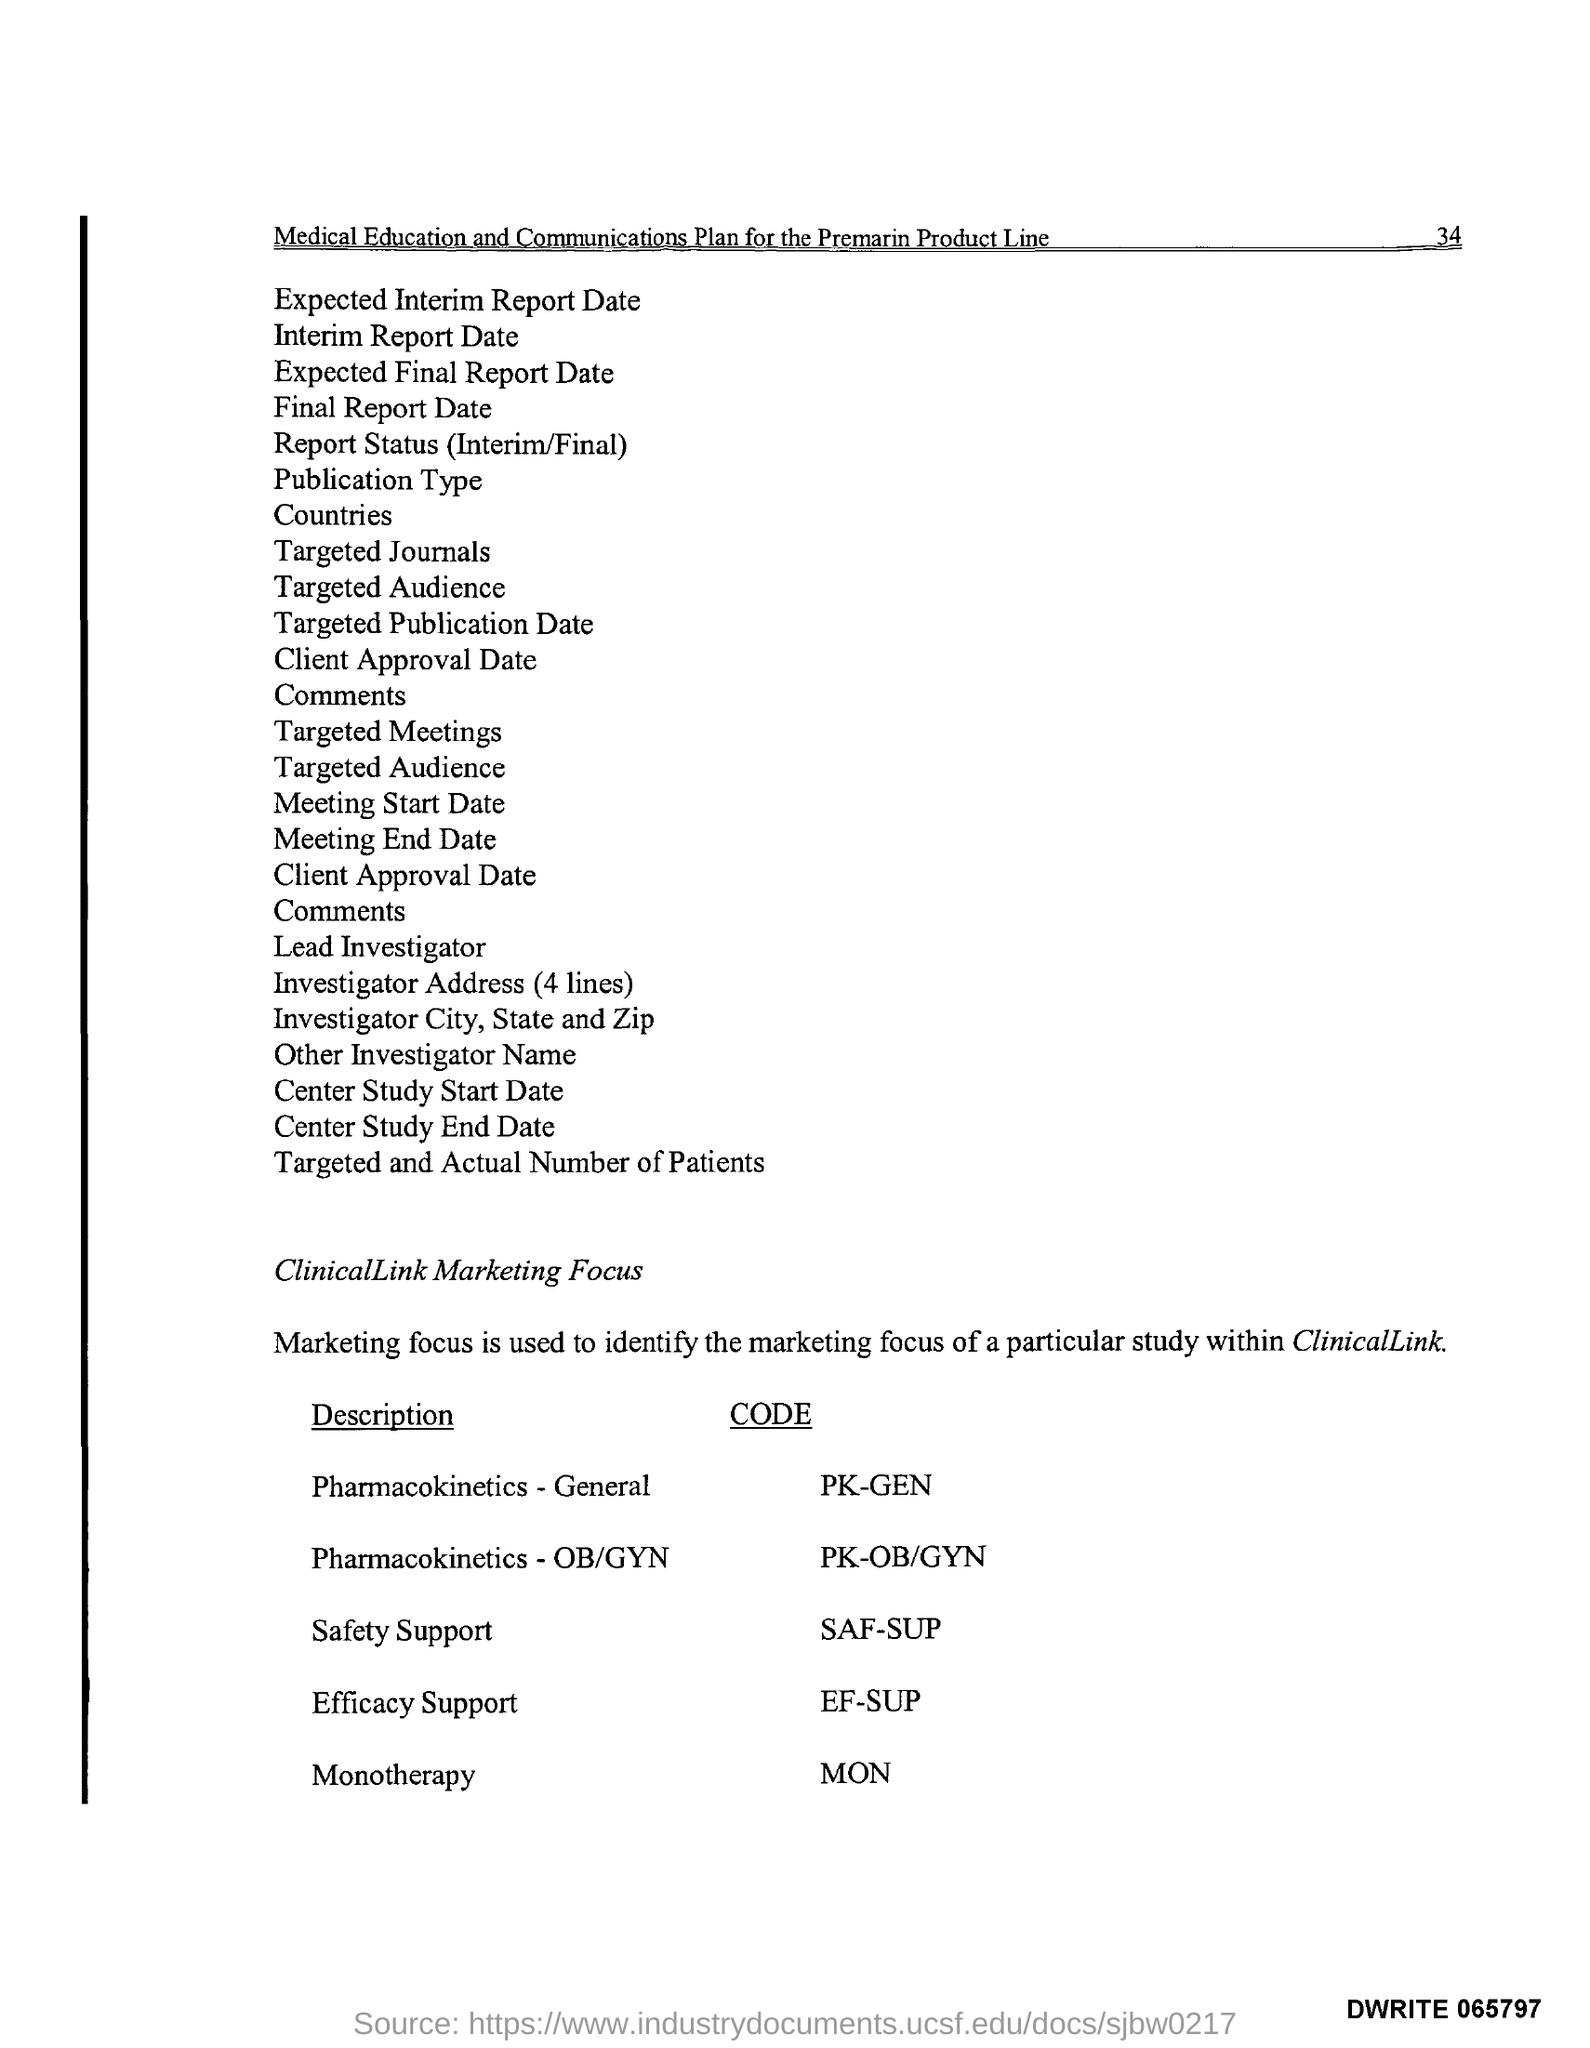How many lines are there in ivestigator's address?
Give a very brief answer. 4. 